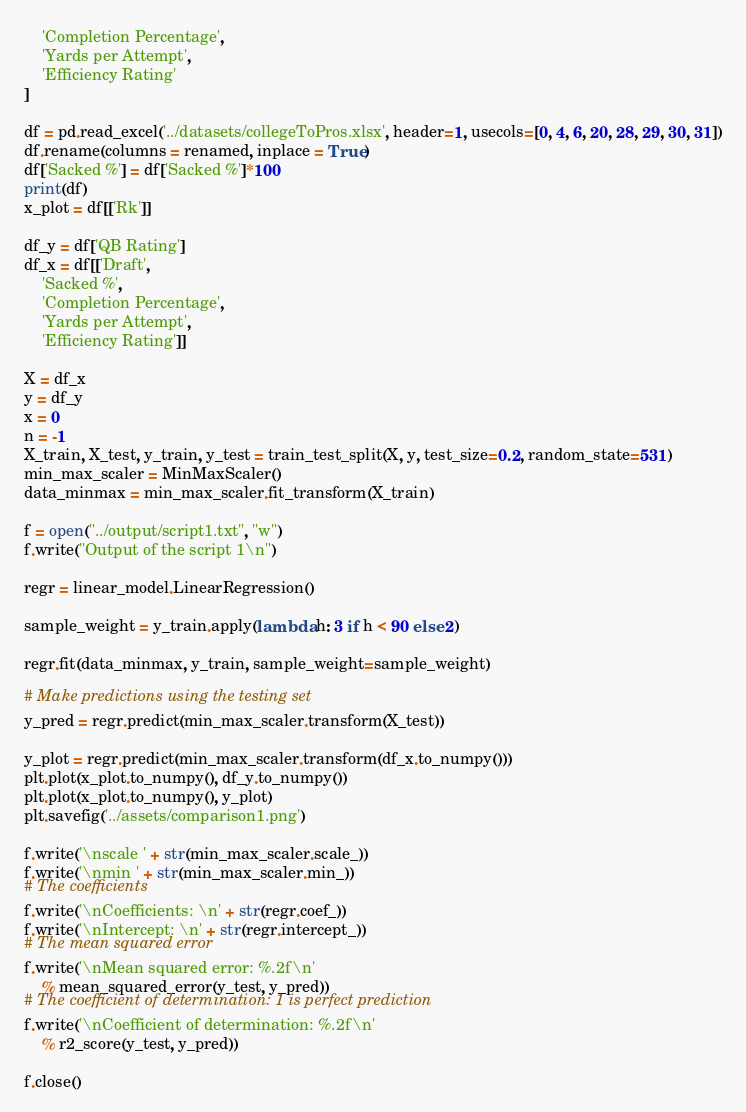Convert code to text. <code><loc_0><loc_0><loc_500><loc_500><_Python_>    'Completion Percentage',
    'Yards per Attempt',
    'Efficiency Rating'
]

df = pd.read_excel('../datasets/collegeToPros.xlsx', header=1, usecols=[0, 4, 6, 20, 28, 29, 30, 31])
df.rename(columns = renamed, inplace = True)
df['Sacked %'] = df['Sacked %']*100
print(df)
x_plot = df[['Rk']]

df_y = df['QB Rating']
df_x = df[['Draft',
    'Sacked %',
    'Completion Percentage',
    'Yards per Attempt',
    'Efficiency Rating']]

X = df_x
y = df_y
x = 0
n = -1
X_train, X_test, y_train, y_test = train_test_split(X, y, test_size=0.2, random_state=531)
min_max_scaler = MinMaxScaler()
data_minmax = min_max_scaler.fit_transform(X_train)

f = open("../output/script1.txt", "w")
f.write("Output of the script 1\n")

regr = linear_model.LinearRegression()

sample_weight = y_train.apply(lambda h: 3 if h < 90 else 2)

regr.fit(data_minmax, y_train, sample_weight=sample_weight)

# Make predictions using the testing set
y_pred = regr.predict(min_max_scaler.transform(X_test))

y_plot = regr.predict(min_max_scaler.transform(df_x.to_numpy()))
plt.plot(x_plot.to_numpy(), df_y.to_numpy())
plt.plot(x_plot.to_numpy(), y_plot)
plt.savefig('../assets/comparison1.png')

f.write('\nscale ' + str(min_max_scaler.scale_))
f.write('\nmin ' + str(min_max_scaler.min_))
# The coefficients
f.write('\nCoefficients: \n' + str(regr.coef_))
f.write('\nIntercept: \n' + str(regr.intercept_))
# The mean squared error
f.write('\nMean squared error: %.2f\n'
    % mean_squared_error(y_test, y_pred))
# The coefficient of determination: 1 is perfect prediction
f.write('\nCoefficient of determination: %.2f\n'
    % r2_score(y_test, y_pred))

f.close()</code> 